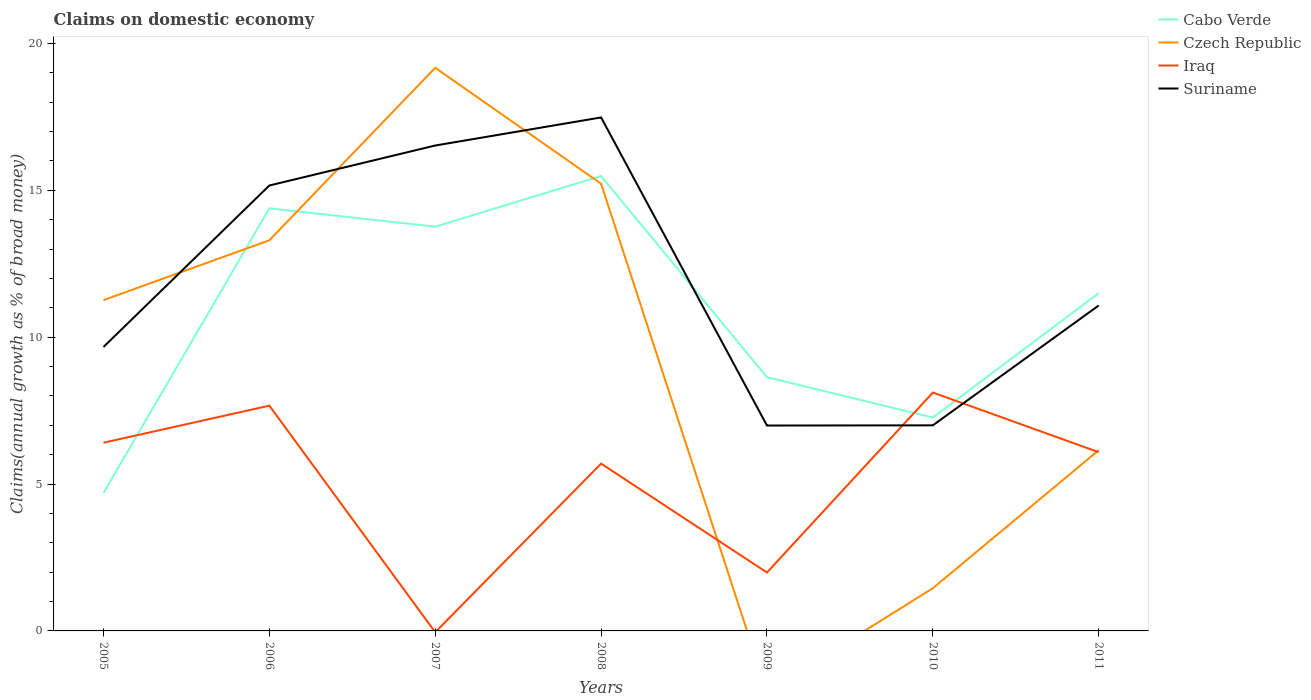Does the line corresponding to Czech Republic intersect with the line corresponding to Cabo Verde?
Your answer should be very brief. Yes. Is the number of lines equal to the number of legend labels?
Your answer should be compact. No. What is the total percentage of broad money claimed on domestic economy in Czech Republic in the graph?
Offer a very short reply. -1.93. What is the difference between the highest and the second highest percentage of broad money claimed on domestic economy in Iraq?
Your response must be concise. 8.12. How many lines are there?
Provide a short and direct response. 4. What is the difference between two consecutive major ticks on the Y-axis?
Offer a terse response. 5. How many legend labels are there?
Your response must be concise. 4. How are the legend labels stacked?
Your response must be concise. Vertical. What is the title of the graph?
Offer a very short reply. Claims on domestic economy. Does "Kazakhstan" appear as one of the legend labels in the graph?
Provide a succinct answer. No. What is the label or title of the Y-axis?
Provide a succinct answer. Claims(annual growth as % of broad money). What is the Claims(annual growth as % of broad money) of Cabo Verde in 2005?
Offer a very short reply. 4.7. What is the Claims(annual growth as % of broad money) of Czech Republic in 2005?
Give a very brief answer. 11.26. What is the Claims(annual growth as % of broad money) of Iraq in 2005?
Keep it short and to the point. 6.41. What is the Claims(annual growth as % of broad money) of Suriname in 2005?
Provide a short and direct response. 9.67. What is the Claims(annual growth as % of broad money) of Cabo Verde in 2006?
Your answer should be compact. 14.39. What is the Claims(annual growth as % of broad money) of Czech Republic in 2006?
Make the answer very short. 13.3. What is the Claims(annual growth as % of broad money) of Iraq in 2006?
Your answer should be very brief. 7.67. What is the Claims(annual growth as % of broad money) in Suriname in 2006?
Your answer should be compact. 15.16. What is the Claims(annual growth as % of broad money) in Cabo Verde in 2007?
Ensure brevity in your answer.  13.76. What is the Claims(annual growth as % of broad money) in Czech Republic in 2007?
Give a very brief answer. 19.17. What is the Claims(annual growth as % of broad money) of Suriname in 2007?
Ensure brevity in your answer.  16.53. What is the Claims(annual growth as % of broad money) of Cabo Verde in 2008?
Your answer should be very brief. 15.49. What is the Claims(annual growth as % of broad money) in Czech Republic in 2008?
Provide a short and direct response. 15.22. What is the Claims(annual growth as % of broad money) in Iraq in 2008?
Offer a very short reply. 5.7. What is the Claims(annual growth as % of broad money) in Suriname in 2008?
Your response must be concise. 17.48. What is the Claims(annual growth as % of broad money) of Cabo Verde in 2009?
Give a very brief answer. 8.64. What is the Claims(annual growth as % of broad money) of Iraq in 2009?
Keep it short and to the point. 1.99. What is the Claims(annual growth as % of broad money) in Suriname in 2009?
Ensure brevity in your answer.  6.99. What is the Claims(annual growth as % of broad money) of Cabo Verde in 2010?
Offer a very short reply. 7.26. What is the Claims(annual growth as % of broad money) of Czech Republic in 2010?
Make the answer very short. 1.45. What is the Claims(annual growth as % of broad money) in Iraq in 2010?
Offer a very short reply. 8.12. What is the Claims(annual growth as % of broad money) of Suriname in 2010?
Your answer should be compact. 7. What is the Claims(annual growth as % of broad money) of Cabo Verde in 2011?
Give a very brief answer. 11.5. What is the Claims(annual growth as % of broad money) in Czech Republic in 2011?
Offer a very short reply. 6.15. What is the Claims(annual growth as % of broad money) in Iraq in 2011?
Ensure brevity in your answer.  6.09. What is the Claims(annual growth as % of broad money) of Suriname in 2011?
Provide a short and direct response. 11.08. Across all years, what is the maximum Claims(annual growth as % of broad money) in Cabo Verde?
Provide a succinct answer. 15.49. Across all years, what is the maximum Claims(annual growth as % of broad money) of Czech Republic?
Make the answer very short. 19.17. Across all years, what is the maximum Claims(annual growth as % of broad money) in Iraq?
Ensure brevity in your answer.  8.12. Across all years, what is the maximum Claims(annual growth as % of broad money) in Suriname?
Make the answer very short. 17.48. Across all years, what is the minimum Claims(annual growth as % of broad money) of Cabo Verde?
Offer a terse response. 4.7. Across all years, what is the minimum Claims(annual growth as % of broad money) in Czech Republic?
Ensure brevity in your answer.  0. Across all years, what is the minimum Claims(annual growth as % of broad money) of Suriname?
Provide a short and direct response. 6.99. What is the total Claims(annual growth as % of broad money) of Cabo Verde in the graph?
Make the answer very short. 75.74. What is the total Claims(annual growth as % of broad money) of Czech Republic in the graph?
Ensure brevity in your answer.  66.57. What is the total Claims(annual growth as % of broad money) of Iraq in the graph?
Your response must be concise. 35.96. What is the total Claims(annual growth as % of broad money) in Suriname in the graph?
Provide a short and direct response. 83.91. What is the difference between the Claims(annual growth as % of broad money) in Cabo Verde in 2005 and that in 2006?
Provide a short and direct response. -9.69. What is the difference between the Claims(annual growth as % of broad money) of Czech Republic in 2005 and that in 2006?
Your answer should be very brief. -2.04. What is the difference between the Claims(annual growth as % of broad money) in Iraq in 2005 and that in 2006?
Offer a terse response. -1.26. What is the difference between the Claims(annual growth as % of broad money) of Suriname in 2005 and that in 2006?
Provide a short and direct response. -5.5. What is the difference between the Claims(annual growth as % of broad money) of Cabo Verde in 2005 and that in 2007?
Provide a short and direct response. -9.07. What is the difference between the Claims(annual growth as % of broad money) in Czech Republic in 2005 and that in 2007?
Provide a succinct answer. -7.91. What is the difference between the Claims(annual growth as % of broad money) in Suriname in 2005 and that in 2007?
Make the answer very short. -6.86. What is the difference between the Claims(annual growth as % of broad money) of Cabo Verde in 2005 and that in 2008?
Make the answer very short. -10.79. What is the difference between the Claims(annual growth as % of broad money) in Czech Republic in 2005 and that in 2008?
Provide a short and direct response. -3.96. What is the difference between the Claims(annual growth as % of broad money) of Iraq in 2005 and that in 2008?
Offer a terse response. 0.71. What is the difference between the Claims(annual growth as % of broad money) of Suriname in 2005 and that in 2008?
Offer a terse response. -7.82. What is the difference between the Claims(annual growth as % of broad money) of Cabo Verde in 2005 and that in 2009?
Your answer should be compact. -3.94. What is the difference between the Claims(annual growth as % of broad money) in Iraq in 2005 and that in 2009?
Your answer should be very brief. 4.42. What is the difference between the Claims(annual growth as % of broad money) of Suriname in 2005 and that in 2009?
Provide a short and direct response. 2.67. What is the difference between the Claims(annual growth as % of broad money) of Cabo Verde in 2005 and that in 2010?
Ensure brevity in your answer.  -2.57. What is the difference between the Claims(annual growth as % of broad money) of Czech Republic in 2005 and that in 2010?
Keep it short and to the point. 9.81. What is the difference between the Claims(annual growth as % of broad money) in Iraq in 2005 and that in 2010?
Offer a very short reply. -1.71. What is the difference between the Claims(annual growth as % of broad money) in Suriname in 2005 and that in 2010?
Your response must be concise. 2.67. What is the difference between the Claims(annual growth as % of broad money) of Cabo Verde in 2005 and that in 2011?
Offer a very short reply. -6.8. What is the difference between the Claims(annual growth as % of broad money) in Czech Republic in 2005 and that in 2011?
Give a very brief answer. 5.11. What is the difference between the Claims(annual growth as % of broad money) of Iraq in 2005 and that in 2011?
Your response must be concise. 0.32. What is the difference between the Claims(annual growth as % of broad money) in Suriname in 2005 and that in 2011?
Offer a very short reply. -1.41. What is the difference between the Claims(annual growth as % of broad money) of Cabo Verde in 2006 and that in 2007?
Ensure brevity in your answer.  0.62. What is the difference between the Claims(annual growth as % of broad money) of Czech Republic in 2006 and that in 2007?
Your answer should be very brief. -5.87. What is the difference between the Claims(annual growth as % of broad money) of Suriname in 2006 and that in 2007?
Give a very brief answer. -1.36. What is the difference between the Claims(annual growth as % of broad money) of Cabo Verde in 2006 and that in 2008?
Your answer should be compact. -1.1. What is the difference between the Claims(annual growth as % of broad money) in Czech Republic in 2006 and that in 2008?
Give a very brief answer. -1.93. What is the difference between the Claims(annual growth as % of broad money) in Iraq in 2006 and that in 2008?
Ensure brevity in your answer.  1.97. What is the difference between the Claims(annual growth as % of broad money) of Suriname in 2006 and that in 2008?
Your answer should be very brief. -2.32. What is the difference between the Claims(annual growth as % of broad money) of Cabo Verde in 2006 and that in 2009?
Provide a succinct answer. 5.75. What is the difference between the Claims(annual growth as % of broad money) of Iraq in 2006 and that in 2009?
Ensure brevity in your answer.  5.68. What is the difference between the Claims(annual growth as % of broad money) of Suriname in 2006 and that in 2009?
Offer a very short reply. 8.17. What is the difference between the Claims(annual growth as % of broad money) of Cabo Verde in 2006 and that in 2010?
Your answer should be compact. 7.12. What is the difference between the Claims(annual growth as % of broad money) in Czech Republic in 2006 and that in 2010?
Provide a short and direct response. 11.84. What is the difference between the Claims(annual growth as % of broad money) of Iraq in 2006 and that in 2010?
Give a very brief answer. -0.45. What is the difference between the Claims(annual growth as % of broad money) of Suriname in 2006 and that in 2010?
Provide a short and direct response. 8.17. What is the difference between the Claims(annual growth as % of broad money) of Cabo Verde in 2006 and that in 2011?
Offer a very short reply. 2.89. What is the difference between the Claims(annual growth as % of broad money) in Czech Republic in 2006 and that in 2011?
Your response must be concise. 7.15. What is the difference between the Claims(annual growth as % of broad money) in Iraq in 2006 and that in 2011?
Provide a short and direct response. 1.58. What is the difference between the Claims(annual growth as % of broad money) in Suriname in 2006 and that in 2011?
Keep it short and to the point. 4.09. What is the difference between the Claims(annual growth as % of broad money) in Cabo Verde in 2007 and that in 2008?
Offer a very short reply. -1.72. What is the difference between the Claims(annual growth as % of broad money) in Czech Republic in 2007 and that in 2008?
Provide a succinct answer. 3.95. What is the difference between the Claims(annual growth as % of broad money) of Suriname in 2007 and that in 2008?
Keep it short and to the point. -0.96. What is the difference between the Claims(annual growth as % of broad money) of Cabo Verde in 2007 and that in 2009?
Give a very brief answer. 5.12. What is the difference between the Claims(annual growth as % of broad money) of Suriname in 2007 and that in 2009?
Your answer should be very brief. 9.53. What is the difference between the Claims(annual growth as % of broad money) in Cabo Verde in 2007 and that in 2010?
Provide a short and direct response. 6.5. What is the difference between the Claims(annual growth as % of broad money) of Czech Republic in 2007 and that in 2010?
Your answer should be compact. 17.72. What is the difference between the Claims(annual growth as % of broad money) of Suriname in 2007 and that in 2010?
Provide a succinct answer. 9.53. What is the difference between the Claims(annual growth as % of broad money) of Cabo Verde in 2007 and that in 2011?
Offer a terse response. 2.26. What is the difference between the Claims(annual growth as % of broad money) of Czech Republic in 2007 and that in 2011?
Your answer should be compact. 13.02. What is the difference between the Claims(annual growth as % of broad money) of Suriname in 2007 and that in 2011?
Keep it short and to the point. 5.45. What is the difference between the Claims(annual growth as % of broad money) of Cabo Verde in 2008 and that in 2009?
Provide a short and direct response. 6.85. What is the difference between the Claims(annual growth as % of broad money) of Iraq in 2008 and that in 2009?
Make the answer very short. 3.71. What is the difference between the Claims(annual growth as % of broad money) of Suriname in 2008 and that in 2009?
Offer a terse response. 10.49. What is the difference between the Claims(annual growth as % of broad money) of Cabo Verde in 2008 and that in 2010?
Give a very brief answer. 8.22. What is the difference between the Claims(annual growth as % of broad money) of Czech Republic in 2008 and that in 2010?
Your response must be concise. 13.77. What is the difference between the Claims(annual growth as % of broad money) of Iraq in 2008 and that in 2010?
Your response must be concise. -2.42. What is the difference between the Claims(annual growth as % of broad money) in Suriname in 2008 and that in 2010?
Offer a very short reply. 10.48. What is the difference between the Claims(annual growth as % of broad money) of Cabo Verde in 2008 and that in 2011?
Make the answer very short. 3.99. What is the difference between the Claims(annual growth as % of broad money) of Czech Republic in 2008 and that in 2011?
Your answer should be very brief. 9.07. What is the difference between the Claims(annual growth as % of broad money) of Iraq in 2008 and that in 2011?
Your response must be concise. -0.39. What is the difference between the Claims(annual growth as % of broad money) in Suriname in 2008 and that in 2011?
Give a very brief answer. 6.4. What is the difference between the Claims(annual growth as % of broad money) in Cabo Verde in 2009 and that in 2010?
Give a very brief answer. 1.37. What is the difference between the Claims(annual growth as % of broad money) in Iraq in 2009 and that in 2010?
Your response must be concise. -6.13. What is the difference between the Claims(annual growth as % of broad money) in Suriname in 2009 and that in 2010?
Your answer should be compact. -0.01. What is the difference between the Claims(annual growth as % of broad money) in Cabo Verde in 2009 and that in 2011?
Your answer should be very brief. -2.86. What is the difference between the Claims(annual growth as % of broad money) in Iraq in 2009 and that in 2011?
Your answer should be compact. -4.1. What is the difference between the Claims(annual growth as % of broad money) of Suriname in 2009 and that in 2011?
Offer a terse response. -4.09. What is the difference between the Claims(annual growth as % of broad money) in Cabo Verde in 2010 and that in 2011?
Offer a very short reply. -4.24. What is the difference between the Claims(annual growth as % of broad money) in Czech Republic in 2010 and that in 2011?
Your response must be concise. -4.7. What is the difference between the Claims(annual growth as % of broad money) in Iraq in 2010 and that in 2011?
Ensure brevity in your answer.  2.03. What is the difference between the Claims(annual growth as % of broad money) in Suriname in 2010 and that in 2011?
Make the answer very short. -4.08. What is the difference between the Claims(annual growth as % of broad money) of Cabo Verde in 2005 and the Claims(annual growth as % of broad money) of Czech Republic in 2006?
Your answer should be very brief. -8.6. What is the difference between the Claims(annual growth as % of broad money) in Cabo Verde in 2005 and the Claims(annual growth as % of broad money) in Iraq in 2006?
Make the answer very short. -2.97. What is the difference between the Claims(annual growth as % of broad money) in Cabo Verde in 2005 and the Claims(annual growth as % of broad money) in Suriname in 2006?
Ensure brevity in your answer.  -10.47. What is the difference between the Claims(annual growth as % of broad money) in Czech Republic in 2005 and the Claims(annual growth as % of broad money) in Iraq in 2006?
Offer a terse response. 3.59. What is the difference between the Claims(annual growth as % of broad money) in Czech Republic in 2005 and the Claims(annual growth as % of broad money) in Suriname in 2006?
Offer a terse response. -3.9. What is the difference between the Claims(annual growth as % of broad money) in Iraq in 2005 and the Claims(annual growth as % of broad money) in Suriname in 2006?
Provide a short and direct response. -8.76. What is the difference between the Claims(annual growth as % of broad money) of Cabo Verde in 2005 and the Claims(annual growth as % of broad money) of Czech Republic in 2007?
Your answer should be very brief. -14.48. What is the difference between the Claims(annual growth as % of broad money) of Cabo Verde in 2005 and the Claims(annual growth as % of broad money) of Suriname in 2007?
Provide a succinct answer. -11.83. What is the difference between the Claims(annual growth as % of broad money) in Czech Republic in 2005 and the Claims(annual growth as % of broad money) in Suriname in 2007?
Make the answer very short. -5.26. What is the difference between the Claims(annual growth as % of broad money) in Iraq in 2005 and the Claims(annual growth as % of broad money) in Suriname in 2007?
Provide a short and direct response. -10.12. What is the difference between the Claims(annual growth as % of broad money) of Cabo Verde in 2005 and the Claims(annual growth as % of broad money) of Czech Republic in 2008?
Make the answer very short. -10.53. What is the difference between the Claims(annual growth as % of broad money) of Cabo Verde in 2005 and the Claims(annual growth as % of broad money) of Iraq in 2008?
Provide a short and direct response. -1. What is the difference between the Claims(annual growth as % of broad money) in Cabo Verde in 2005 and the Claims(annual growth as % of broad money) in Suriname in 2008?
Ensure brevity in your answer.  -12.78. What is the difference between the Claims(annual growth as % of broad money) of Czech Republic in 2005 and the Claims(annual growth as % of broad money) of Iraq in 2008?
Offer a terse response. 5.57. What is the difference between the Claims(annual growth as % of broad money) in Czech Republic in 2005 and the Claims(annual growth as % of broad money) in Suriname in 2008?
Make the answer very short. -6.22. What is the difference between the Claims(annual growth as % of broad money) of Iraq in 2005 and the Claims(annual growth as % of broad money) of Suriname in 2008?
Your answer should be very brief. -11.07. What is the difference between the Claims(annual growth as % of broad money) of Cabo Verde in 2005 and the Claims(annual growth as % of broad money) of Iraq in 2009?
Provide a short and direct response. 2.71. What is the difference between the Claims(annual growth as % of broad money) of Cabo Verde in 2005 and the Claims(annual growth as % of broad money) of Suriname in 2009?
Give a very brief answer. -2.29. What is the difference between the Claims(annual growth as % of broad money) of Czech Republic in 2005 and the Claims(annual growth as % of broad money) of Iraq in 2009?
Your answer should be very brief. 9.27. What is the difference between the Claims(annual growth as % of broad money) in Czech Republic in 2005 and the Claims(annual growth as % of broad money) in Suriname in 2009?
Provide a succinct answer. 4.27. What is the difference between the Claims(annual growth as % of broad money) in Iraq in 2005 and the Claims(annual growth as % of broad money) in Suriname in 2009?
Provide a succinct answer. -0.58. What is the difference between the Claims(annual growth as % of broad money) of Cabo Verde in 2005 and the Claims(annual growth as % of broad money) of Czech Republic in 2010?
Provide a succinct answer. 3.24. What is the difference between the Claims(annual growth as % of broad money) in Cabo Verde in 2005 and the Claims(annual growth as % of broad money) in Iraq in 2010?
Keep it short and to the point. -3.42. What is the difference between the Claims(annual growth as % of broad money) of Cabo Verde in 2005 and the Claims(annual growth as % of broad money) of Suriname in 2010?
Provide a succinct answer. -2.3. What is the difference between the Claims(annual growth as % of broad money) in Czech Republic in 2005 and the Claims(annual growth as % of broad money) in Iraq in 2010?
Make the answer very short. 3.15. What is the difference between the Claims(annual growth as % of broad money) in Czech Republic in 2005 and the Claims(annual growth as % of broad money) in Suriname in 2010?
Ensure brevity in your answer.  4.26. What is the difference between the Claims(annual growth as % of broad money) in Iraq in 2005 and the Claims(annual growth as % of broad money) in Suriname in 2010?
Offer a terse response. -0.59. What is the difference between the Claims(annual growth as % of broad money) of Cabo Verde in 2005 and the Claims(annual growth as % of broad money) of Czech Republic in 2011?
Offer a terse response. -1.46. What is the difference between the Claims(annual growth as % of broad money) of Cabo Verde in 2005 and the Claims(annual growth as % of broad money) of Iraq in 2011?
Your answer should be very brief. -1.39. What is the difference between the Claims(annual growth as % of broad money) of Cabo Verde in 2005 and the Claims(annual growth as % of broad money) of Suriname in 2011?
Your response must be concise. -6.38. What is the difference between the Claims(annual growth as % of broad money) of Czech Republic in 2005 and the Claims(annual growth as % of broad money) of Iraq in 2011?
Provide a succinct answer. 5.18. What is the difference between the Claims(annual growth as % of broad money) of Czech Republic in 2005 and the Claims(annual growth as % of broad money) of Suriname in 2011?
Your answer should be compact. 0.18. What is the difference between the Claims(annual growth as % of broad money) in Iraq in 2005 and the Claims(annual growth as % of broad money) in Suriname in 2011?
Give a very brief answer. -4.67. What is the difference between the Claims(annual growth as % of broad money) in Cabo Verde in 2006 and the Claims(annual growth as % of broad money) in Czech Republic in 2007?
Your response must be concise. -4.79. What is the difference between the Claims(annual growth as % of broad money) in Cabo Verde in 2006 and the Claims(annual growth as % of broad money) in Suriname in 2007?
Your answer should be compact. -2.14. What is the difference between the Claims(annual growth as % of broad money) of Czech Republic in 2006 and the Claims(annual growth as % of broad money) of Suriname in 2007?
Ensure brevity in your answer.  -3.23. What is the difference between the Claims(annual growth as % of broad money) of Iraq in 2006 and the Claims(annual growth as % of broad money) of Suriname in 2007?
Your answer should be compact. -8.86. What is the difference between the Claims(annual growth as % of broad money) of Cabo Verde in 2006 and the Claims(annual growth as % of broad money) of Czech Republic in 2008?
Keep it short and to the point. -0.84. What is the difference between the Claims(annual growth as % of broad money) in Cabo Verde in 2006 and the Claims(annual growth as % of broad money) in Iraq in 2008?
Offer a terse response. 8.69. What is the difference between the Claims(annual growth as % of broad money) in Cabo Verde in 2006 and the Claims(annual growth as % of broad money) in Suriname in 2008?
Your answer should be compact. -3.09. What is the difference between the Claims(annual growth as % of broad money) of Czech Republic in 2006 and the Claims(annual growth as % of broad money) of Iraq in 2008?
Provide a short and direct response. 7.6. What is the difference between the Claims(annual growth as % of broad money) of Czech Republic in 2006 and the Claims(annual growth as % of broad money) of Suriname in 2008?
Provide a short and direct response. -4.18. What is the difference between the Claims(annual growth as % of broad money) in Iraq in 2006 and the Claims(annual growth as % of broad money) in Suriname in 2008?
Your answer should be very brief. -9.81. What is the difference between the Claims(annual growth as % of broad money) of Cabo Verde in 2006 and the Claims(annual growth as % of broad money) of Iraq in 2009?
Your answer should be compact. 12.4. What is the difference between the Claims(annual growth as % of broad money) of Cabo Verde in 2006 and the Claims(annual growth as % of broad money) of Suriname in 2009?
Your answer should be very brief. 7.39. What is the difference between the Claims(annual growth as % of broad money) in Czech Republic in 2006 and the Claims(annual growth as % of broad money) in Iraq in 2009?
Ensure brevity in your answer.  11.31. What is the difference between the Claims(annual growth as % of broad money) of Czech Republic in 2006 and the Claims(annual growth as % of broad money) of Suriname in 2009?
Provide a succinct answer. 6.31. What is the difference between the Claims(annual growth as % of broad money) in Iraq in 2006 and the Claims(annual growth as % of broad money) in Suriname in 2009?
Your answer should be compact. 0.68. What is the difference between the Claims(annual growth as % of broad money) of Cabo Verde in 2006 and the Claims(annual growth as % of broad money) of Czech Republic in 2010?
Ensure brevity in your answer.  12.93. What is the difference between the Claims(annual growth as % of broad money) in Cabo Verde in 2006 and the Claims(annual growth as % of broad money) in Iraq in 2010?
Your response must be concise. 6.27. What is the difference between the Claims(annual growth as % of broad money) in Cabo Verde in 2006 and the Claims(annual growth as % of broad money) in Suriname in 2010?
Provide a succinct answer. 7.39. What is the difference between the Claims(annual growth as % of broad money) in Czech Republic in 2006 and the Claims(annual growth as % of broad money) in Iraq in 2010?
Make the answer very short. 5.18. What is the difference between the Claims(annual growth as % of broad money) in Czech Republic in 2006 and the Claims(annual growth as % of broad money) in Suriname in 2010?
Give a very brief answer. 6.3. What is the difference between the Claims(annual growth as % of broad money) in Iraq in 2006 and the Claims(annual growth as % of broad money) in Suriname in 2010?
Your response must be concise. 0.67. What is the difference between the Claims(annual growth as % of broad money) of Cabo Verde in 2006 and the Claims(annual growth as % of broad money) of Czech Republic in 2011?
Offer a very short reply. 8.23. What is the difference between the Claims(annual growth as % of broad money) in Cabo Verde in 2006 and the Claims(annual growth as % of broad money) in Iraq in 2011?
Provide a short and direct response. 8.3. What is the difference between the Claims(annual growth as % of broad money) of Cabo Verde in 2006 and the Claims(annual growth as % of broad money) of Suriname in 2011?
Offer a very short reply. 3.31. What is the difference between the Claims(annual growth as % of broad money) in Czech Republic in 2006 and the Claims(annual growth as % of broad money) in Iraq in 2011?
Make the answer very short. 7.21. What is the difference between the Claims(annual growth as % of broad money) in Czech Republic in 2006 and the Claims(annual growth as % of broad money) in Suriname in 2011?
Your response must be concise. 2.22. What is the difference between the Claims(annual growth as % of broad money) of Iraq in 2006 and the Claims(annual growth as % of broad money) of Suriname in 2011?
Give a very brief answer. -3.41. What is the difference between the Claims(annual growth as % of broad money) in Cabo Verde in 2007 and the Claims(annual growth as % of broad money) in Czech Republic in 2008?
Your response must be concise. -1.46. What is the difference between the Claims(annual growth as % of broad money) of Cabo Verde in 2007 and the Claims(annual growth as % of broad money) of Iraq in 2008?
Provide a short and direct response. 8.07. What is the difference between the Claims(annual growth as % of broad money) in Cabo Verde in 2007 and the Claims(annual growth as % of broad money) in Suriname in 2008?
Offer a very short reply. -3.72. What is the difference between the Claims(annual growth as % of broad money) of Czech Republic in 2007 and the Claims(annual growth as % of broad money) of Iraq in 2008?
Give a very brief answer. 13.48. What is the difference between the Claims(annual growth as % of broad money) of Czech Republic in 2007 and the Claims(annual growth as % of broad money) of Suriname in 2008?
Provide a succinct answer. 1.69. What is the difference between the Claims(annual growth as % of broad money) in Cabo Verde in 2007 and the Claims(annual growth as % of broad money) in Iraq in 2009?
Provide a succinct answer. 11.77. What is the difference between the Claims(annual growth as % of broad money) of Cabo Verde in 2007 and the Claims(annual growth as % of broad money) of Suriname in 2009?
Provide a short and direct response. 6.77. What is the difference between the Claims(annual growth as % of broad money) in Czech Republic in 2007 and the Claims(annual growth as % of broad money) in Iraq in 2009?
Keep it short and to the point. 17.18. What is the difference between the Claims(annual growth as % of broad money) of Czech Republic in 2007 and the Claims(annual growth as % of broad money) of Suriname in 2009?
Offer a very short reply. 12.18. What is the difference between the Claims(annual growth as % of broad money) in Cabo Verde in 2007 and the Claims(annual growth as % of broad money) in Czech Republic in 2010?
Provide a succinct answer. 12.31. What is the difference between the Claims(annual growth as % of broad money) of Cabo Verde in 2007 and the Claims(annual growth as % of broad money) of Iraq in 2010?
Give a very brief answer. 5.65. What is the difference between the Claims(annual growth as % of broad money) in Cabo Verde in 2007 and the Claims(annual growth as % of broad money) in Suriname in 2010?
Provide a succinct answer. 6.76. What is the difference between the Claims(annual growth as % of broad money) in Czech Republic in 2007 and the Claims(annual growth as % of broad money) in Iraq in 2010?
Your response must be concise. 11.06. What is the difference between the Claims(annual growth as % of broad money) in Czech Republic in 2007 and the Claims(annual growth as % of broad money) in Suriname in 2010?
Your answer should be very brief. 12.17. What is the difference between the Claims(annual growth as % of broad money) in Cabo Verde in 2007 and the Claims(annual growth as % of broad money) in Czech Republic in 2011?
Give a very brief answer. 7.61. What is the difference between the Claims(annual growth as % of broad money) of Cabo Verde in 2007 and the Claims(annual growth as % of broad money) of Iraq in 2011?
Your response must be concise. 7.68. What is the difference between the Claims(annual growth as % of broad money) in Cabo Verde in 2007 and the Claims(annual growth as % of broad money) in Suriname in 2011?
Provide a short and direct response. 2.68. What is the difference between the Claims(annual growth as % of broad money) in Czech Republic in 2007 and the Claims(annual growth as % of broad money) in Iraq in 2011?
Keep it short and to the point. 13.09. What is the difference between the Claims(annual growth as % of broad money) of Czech Republic in 2007 and the Claims(annual growth as % of broad money) of Suriname in 2011?
Give a very brief answer. 8.09. What is the difference between the Claims(annual growth as % of broad money) of Cabo Verde in 2008 and the Claims(annual growth as % of broad money) of Iraq in 2009?
Provide a short and direct response. 13.5. What is the difference between the Claims(annual growth as % of broad money) of Cabo Verde in 2008 and the Claims(annual growth as % of broad money) of Suriname in 2009?
Give a very brief answer. 8.49. What is the difference between the Claims(annual growth as % of broad money) of Czech Republic in 2008 and the Claims(annual growth as % of broad money) of Iraq in 2009?
Ensure brevity in your answer.  13.24. What is the difference between the Claims(annual growth as % of broad money) of Czech Republic in 2008 and the Claims(annual growth as % of broad money) of Suriname in 2009?
Make the answer very short. 8.23. What is the difference between the Claims(annual growth as % of broad money) in Iraq in 2008 and the Claims(annual growth as % of broad money) in Suriname in 2009?
Keep it short and to the point. -1.3. What is the difference between the Claims(annual growth as % of broad money) of Cabo Verde in 2008 and the Claims(annual growth as % of broad money) of Czech Republic in 2010?
Your answer should be compact. 14.03. What is the difference between the Claims(annual growth as % of broad money) in Cabo Verde in 2008 and the Claims(annual growth as % of broad money) in Iraq in 2010?
Provide a short and direct response. 7.37. What is the difference between the Claims(annual growth as % of broad money) in Cabo Verde in 2008 and the Claims(annual growth as % of broad money) in Suriname in 2010?
Offer a terse response. 8.49. What is the difference between the Claims(annual growth as % of broad money) in Czech Republic in 2008 and the Claims(annual growth as % of broad money) in Iraq in 2010?
Keep it short and to the point. 7.11. What is the difference between the Claims(annual growth as % of broad money) in Czech Republic in 2008 and the Claims(annual growth as % of broad money) in Suriname in 2010?
Provide a short and direct response. 8.23. What is the difference between the Claims(annual growth as % of broad money) of Iraq in 2008 and the Claims(annual growth as % of broad money) of Suriname in 2010?
Offer a very short reply. -1.3. What is the difference between the Claims(annual growth as % of broad money) of Cabo Verde in 2008 and the Claims(annual growth as % of broad money) of Czech Republic in 2011?
Your response must be concise. 9.33. What is the difference between the Claims(annual growth as % of broad money) of Cabo Verde in 2008 and the Claims(annual growth as % of broad money) of Iraq in 2011?
Your answer should be compact. 9.4. What is the difference between the Claims(annual growth as % of broad money) in Cabo Verde in 2008 and the Claims(annual growth as % of broad money) in Suriname in 2011?
Your answer should be compact. 4.41. What is the difference between the Claims(annual growth as % of broad money) of Czech Republic in 2008 and the Claims(annual growth as % of broad money) of Iraq in 2011?
Offer a terse response. 9.14. What is the difference between the Claims(annual growth as % of broad money) of Czech Republic in 2008 and the Claims(annual growth as % of broad money) of Suriname in 2011?
Give a very brief answer. 4.15. What is the difference between the Claims(annual growth as % of broad money) of Iraq in 2008 and the Claims(annual growth as % of broad money) of Suriname in 2011?
Make the answer very short. -5.38. What is the difference between the Claims(annual growth as % of broad money) in Cabo Verde in 2009 and the Claims(annual growth as % of broad money) in Czech Republic in 2010?
Your response must be concise. 7.18. What is the difference between the Claims(annual growth as % of broad money) in Cabo Verde in 2009 and the Claims(annual growth as % of broad money) in Iraq in 2010?
Keep it short and to the point. 0.52. What is the difference between the Claims(annual growth as % of broad money) of Cabo Verde in 2009 and the Claims(annual growth as % of broad money) of Suriname in 2010?
Keep it short and to the point. 1.64. What is the difference between the Claims(annual growth as % of broad money) in Iraq in 2009 and the Claims(annual growth as % of broad money) in Suriname in 2010?
Offer a terse response. -5.01. What is the difference between the Claims(annual growth as % of broad money) of Cabo Verde in 2009 and the Claims(annual growth as % of broad money) of Czech Republic in 2011?
Offer a terse response. 2.49. What is the difference between the Claims(annual growth as % of broad money) of Cabo Verde in 2009 and the Claims(annual growth as % of broad money) of Iraq in 2011?
Your response must be concise. 2.55. What is the difference between the Claims(annual growth as % of broad money) in Cabo Verde in 2009 and the Claims(annual growth as % of broad money) in Suriname in 2011?
Offer a very short reply. -2.44. What is the difference between the Claims(annual growth as % of broad money) of Iraq in 2009 and the Claims(annual growth as % of broad money) of Suriname in 2011?
Ensure brevity in your answer.  -9.09. What is the difference between the Claims(annual growth as % of broad money) in Cabo Verde in 2010 and the Claims(annual growth as % of broad money) in Czech Republic in 2011?
Offer a very short reply. 1.11. What is the difference between the Claims(annual growth as % of broad money) in Cabo Verde in 2010 and the Claims(annual growth as % of broad money) in Iraq in 2011?
Make the answer very short. 1.18. What is the difference between the Claims(annual growth as % of broad money) in Cabo Verde in 2010 and the Claims(annual growth as % of broad money) in Suriname in 2011?
Provide a short and direct response. -3.81. What is the difference between the Claims(annual growth as % of broad money) of Czech Republic in 2010 and the Claims(annual growth as % of broad money) of Iraq in 2011?
Provide a succinct answer. -4.63. What is the difference between the Claims(annual growth as % of broad money) of Czech Republic in 2010 and the Claims(annual growth as % of broad money) of Suriname in 2011?
Your answer should be very brief. -9.62. What is the difference between the Claims(annual growth as % of broad money) of Iraq in 2010 and the Claims(annual growth as % of broad money) of Suriname in 2011?
Offer a very short reply. -2.96. What is the average Claims(annual growth as % of broad money) of Cabo Verde per year?
Provide a short and direct response. 10.82. What is the average Claims(annual growth as % of broad money) in Czech Republic per year?
Offer a terse response. 9.51. What is the average Claims(annual growth as % of broad money) in Iraq per year?
Offer a very short reply. 5.14. What is the average Claims(annual growth as % of broad money) of Suriname per year?
Make the answer very short. 11.99. In the year 2005, what is the difference between the Claims(annual growth as % of broad money) in Cabo Verde and Claims(annual growth as % of broad money) in Czech Republic?
Your answer should be compact. -6.56. In the year 2005, what is the difference between the Claims(annual growth as % of broad money) of Cabo Verde and Claims(annual growth as % of broad money) of Iraq?
Provide a succinct answer. -1.71. In the year 2005, what is the difference between the Claims(annual growth as % of broad money) of Cabo Verde and Claims(annual growth as % of broad money) of Suriname?
Ensure brevity in your answer.  -4.97. In the year 2005, what is the difference between the Claims(annual growth as % of broad money) of Czech Republic and Claims(annual growth as % of broad money) of Iraq?
Keep it short and to the point. 4.85. In the year 2005, what is the difference between the Claims(annual growth as % of broad money) in Czech Republic and Claims(annual growth as % of broad money) in Suriname?
Ensure brevity in your answer.  1.6. In the year 2005, what is the difference between the Claims(annual growth as % of broad money) in Iraq and Claims(annual growth as % of broad money) in Suriname?
Give a very brief answer. -3.26. In the year 2006, what is the difference between the Claims(annual growth as % of broad money) in Cabo Verde and Claims(annual growth as % of broad money) in Czech Republic?
Offer a terse response. 1.09. In the year 2006, what is the difference between the Claims(annual growth as % of broad money) in Cabo Verde and Claims(annual growth as % of broad money) in Iraq?
Offer a very short reply. 6.72. In the year 2006, what is the difference between the Claims(annual growth as % of broad money) of Cabo Verde and Claims(annual growth as % of broad money) of Suriname?
Make the answer very short. -0.78. In the year 2006, what is the difference between the Claims(annual growth as % of broad money) in Czech Republic and Claims(annual growth as % of broad money) in Iraq?
Give a very brief answer. 5.63. In the year 2006, what is the difference between the Claims(annual growth as % of broad money) in Czech Republic and Claims(annual growth as % of broad money) in Suriname?
Ensure brevity in your answer.  -1.87. In the year 2006, what is the difference between the Claims(annual growth as % of broad money) of Iraq and Claims(annual growth as % of broad money) of Suriname?
Provide a short and direct response. -7.5. In the year 2007, what is the difference between the Claims(annual growth as % of broad money) in Cabo Verde and Claims(annual growth as % of broad money) in Czech Republic?
Provide a short and direct response. -5.41. In the year 2007, what is the difference between the Claims(annual growth as % of broad money) of Cabo Verde and Claims(annual growth as % of broad money) of Suriname?
Offer a terse response. -2.76. In the year 2007, what is the difference between the Claims(annual growth as % of broad money) in Czech Republic and Claims(annual growth as % of broad money) in Suriname?
Give a very brief answer. 2.65. In the year 2008, what is the difference between the Claims(annual growth as % of broad money) of Cabo Verde and Claims(annual growth as % of broad money) of Czech Republic?
Offer a very short reply. 0.26. In the year 2008, what is the difference between the Claims(annual growth as % of broad money) in Cabo Verde and Claims(annual growth as % of broad money) in Iraq?
Give a very brief answer. 9.79. In the year 2008, what is the difference between the Claims(annual growth as % of broad money) of Cabo Verde and Claims(annual growth as % of broad money) of Suriname?
Give a very brief answer. -1.99. In the year 2008, what is the difference between the Claims(annual growth as % of broad money) of Czech Republic and Claims(annual growth as % of broad money) of Iraq?
Keep it short and to the point. 9.53. In the year 2008, what is the difference between the Claims(annual growth as % of broad money) of Czech Republic and Claims(annual growth as % of broad money) of Suriname?
Provide a succinct answer. -2.26. In the year 2008, what is the difference between the Claims(annual growth as % of broad money) in Iraq and Claims(annual growth as % of broad money) in Suriname?
Provide a short and direct response. -11.79. In the year 2009, what is the difference between the Claims(annual growth as % of broad money) of Cabo Verde and Claims(annual growth as % of broad money) of Iraq?
Your response must be concise. 6.65. In the year 2009, what is the difference between the Claims(annual growth as % of broad money) of Cabo Verde and Claims(annual growth as % of broad money) of Suriname?
Ensure brevity in your answer.  1.65. In the year 2009, what is the difference between the Claims(annual growth as % of broad money) of Iraq and Claims(annual growth as % of broad money) of Suriname?
Give a very brief answer. -5. In the year 2010, what is the difference between the Claims(annual growth as % of broad money) of Cabo Verde and Claims(annual growth as % of broad money) of Czech Republic?
Offer a very short reply. 5.81. In the year 2010, what is the difference between the Claims(annual growth as % of broad money) in Cabo Verde and Claims(annual growth as % of broad money) in Iraq?
Give a very brief answer. -0.85. In the year 2010, what is the difference between the Claims(annual growth as % of broad money) of Cabo Verde and Claims(annual growth as % of broad money) of Suriname?
Offer a very short reply. 0.27. In the year 2010, what is the difference between the Claims(annual growth as % of broad money) of Czech Republic and Claims(annual growth as % of broad money) of Iraq?
Your answer should be very brief. -6.66. In the year 2010, what is the difference between the Claims(annual growth as % of broad money) in Czech Republic and Claims(annual growth as % of broad money) in Suriname?
Provide a short and direct response. -5.54. In the year 2010, what is the difference between the Claims(annual growth as % of broad money) in Iraq and Claims(annual growth as % of broad money) in Suriname?
Provide a short and direct response. 1.12. In the year 2011, what is the difference between the Claims(annual growth as % of broad money) of Cabo Verde and Claims(annual growth as % of broad money) of Czech Republic?
Your answer should be compact. 5.35. In the year 2011, what is the difference between the Claims(annual growth as % of broad money) of Cabo Verde and Claims(annual growth as % of broad money) of Iraq?
Your answer should be very brief. 5.42. In the year 2011, what is the difference between the Claims(annual growth as % of broad money) of Cabo Verde and Claims(annual growth as % of broad money) of Suriname?
Your answer should be very brief. 0.42. In the year 2011, what is the difference between the Claims(annual growth as % of broad money) of Czech Republic and Claims(annual growth as % of broad money) of Iraq?
Your answer should be compact. 0.07. In the year 2011, what is the difference between the Claims(annual growth as % of broad money) in Czech Republic and Claims(annual growth as % of broad money) in Suriname?
Your answer should be very brief. -4.93. In the year 2011, what is the difference between the Claims(annual growth as % of broad money) of Iraq and Claims(annual growth as % of broad money) of Suriname?
Your answer should be compact. -4.99. What is the ratio of the Claims(annual growth as % of broad money) of Cabo Verde in 2005 to that in 2006?
Your response must be concise. 0.33. What is the ratio of the Claims(annual growth as % of broad money) of Czech Republic in 2005 to that in 2006?
Give a very brief answer. 0.85. What is the ratio of the Claims(annual growth as % of broad money) of Iraq in 2005 to that in 2006?
Your response must be concise. 0.84. What is the ratio of the Claims(annual growth as % of broad money) in Suriname in 2005 to that in 2006?
Offer a very short reply. 0.64. What is the ratio of the Claims(annual growth as % of broad money) of Cabo Verde in 2005 to that in 2007?
Ensure brevity in your answer.  0.34. What is the ratio of the Claims(annual growth as % of broad money) of Czech Republic in 2005 to that in 2007?
Ensure brevity in your answer.  0.59. What is the ratio of the Claims(annual growth as % of broad money) of Suriname in 2005 to that in 2007?
Offer a terse response. 0.58. What is the ratio of the Claims(annual growth as % of broad money) in Cabo Verde in 2005 to that in 2008?
Provide a succinct answer. 0.3. What is the ratio of the Claims(annual growth as % of broad money) of Czech Republic in 2005 to that in 2008?
Make the answer very short. 0.74. What is the ratio of the Claims(annual growth as % of broad money) of Iraq in 2005 to that in 2008?
Ensure brevity in your answer.  1.12. What is the ratio of the Claims(annual growth as % of broad money) of Suriname in 2005 to that in 2008?
Ensure brevity in your answer.  0.55. What is the ratio of the Claims(annual growth as % of broad money) of Cabo Verde in 2005 to that in 2009?
Offer a terse response. 0.54. What is the ratio of the Claims(annual growth as % of broad money) of Iraq in 2005 to that in 2009?
Provide a short and direct response. 3.22. What is the ratio of the Claims(annual growth as % of broad money) of Suriname in 2005 to that in 2009?
Your response must be concise. 1.38. What is the ratio of the Claims(annual growth as % of broad money) in Cabo Verde in 2005 to that in 2010?
Make the answer very short. 0.65. What is the ratio of the Claims(annual growth as % of broad money) of Czech Republic in 2005 to that in 2010?
Provide a short and direct response. 7.74. What is the ratio of the Claims(annual growth as % of broad money) of Iraq in 2005 to that in 2010?
Provide a short and direct response. 0.79. What is the ratio of the Claims(annual growth as % of broad money) of Suriname in 2005 to that in 2010?
Make the answer very short. 1.38. What is the ratio of the Claims(annual growth as % of broad money) in Cabo Verde in 2005 to that in 2011?
Offer a very short reply. 0.41. What is the ratio of the Claims(annual growth as % of broad money) of Czech Republic in 2005 to that in 2011?
Provide a succinct answer. 1.83. What is the ratio of the Claims(annual growth as % of broad money) in Iraq in 2005 to that in 2011?
Your answer should be compact. 1.05. What is the ratio of the Claims(annual growth as % of broad money) of Suriname in 2005 to that in 2011?
Give a very brief answer. 0.87. What is the ratio of the Claims(annual growth as % of broad money) in Cabo Verde in 2006 to that in 2007?
Make the answer very short. 1.05. What is the ratio of the Claims(annual growth as % of broad money) in Czech Republic in 2006 to that in 2007?
Your answer should be very brief. 0.69. What is the ratio of the Claims(annual growth as % of broad money) of Suriname in 2006 to that in 2007?
Your response must be concise. 0.92. What is the ratio of the Claims(annual growth as % of broad money) in Cabo Verde in 2006 to that in 2008?
Make the answer very short. 0.93. What is the ratio of the Claims(annual growth as % of broad money) of Czech Republic in 2006 to that in 2008?
Your answer should be very brief. 0.87. What is the ratio of the Claims(annual growth as % of broad money) in Iraq in 2006 to that in 2008?
Your answer should be compact. 1.35. What is the ratio of the Claims(annual growth as % of broad money) in Suriname in 2006 to that in 2008?
Your answer should be compact. 0.87. What is the ratio of the Claims(annual growth as % of broad money) in Cabo Verde in 2006 to that in 2009?
Offer a very short reply. 1.67. What is the ratio of the Claims(annual growth as % of broad money) of Iraq in 2006 to that in 2009?
Keep it short and to the point. 3.86. What is the ratio of the Claims(annual growth as % of broad money) of Suriname in 2006 to that in 2009?
Provide a short and direct response. 2.17. What is the ratio of the Claims(annual growth as % of broad money) of Cabo Verde in 2006 to that in 2010?
Provide a succinct answer. 1.98. What is the ratio of the Claims(annual growth as % of broad money) in Czech Republic in 2006 to that in 2010?
Your answer should be compact. 9.15. What is the ratio of the Claims(annual growth as % of broad money) of Iraq in 2006 to that in 2010?
Your answer should be compact. 0.94. What is the ratio of the Claims(annual growth as % of broad money) in Suriname in 2006 to that in 2010?
Ensure brevity in your answer.  2.17. What is the ratio of the Claims(annual growth as % of broad money) in Cabo Verde in 2006 to that in 2011?
Make the answer very short. 1.25. What is the ratio of the Claims(annual growth as % of broad money) of Czech Republic in 2006 to that in 2011?
Provide a succinct answer. 2.16. What is the ratio of the Claims(annual growth as % of broad money) in Iraq in 2006 to that in 2011?
Make the answer very short. 1.26. What is the ratio of the Claims(annual growth as % of broad money) of Suriname in 2006 to that in 2011?
Provide a short and direct response. 1.37. What is the ratio of the Claims(annual growth as % of broad money) of Cabo Verde in 2007 to that in 2008?
Ensure brevity in your answer.  0.89. What is the ratio of the Claims(annual growth as % of broad money) in Czech Republic in 2007 to that in 2008?
Your response must be concise. 1.26. What is the ratio of the Claims(annual growth as % of broad money) of Suriname in 2007 to that in 2008?
Your answer should be very brief. 0.95. What is the ratio of the Claims(annual growth as % of broad money) of Cabo Verde in 2007 to that in 2009?
Ensure brevity in your answer.  1.59. What is the ratio of the Claims(annual growth as % of broad money) of Suriname in 2007 to that in 2009?
Offer a terse response. 2.36. What is the ratio of the Claims(annual growth as % of broad money) of Cabo Verde in 2007 to that in 2010?
Your response must be concise. 1.89. What is the ratio of the Claims(annual growth as % of broad money) of Czech Republic in 2007 to that in 2010?
Offer a terse response. 13.18. What is the ratio of the Claims(annual growth as % of broad money) of Suriname in 2007 to that in 2010?
Keep it short and to the point. 2.36. What is the ratio of the Claims(annual growth as % of broad money) in Cabo Verde in 2007 to that in 2011?
Make the answer very short. 1.2. What is the ratio of the Claims(annual growth as % of broad money) in Czech Republic in 2007 to that in 2011?
Offer a very short reply. 3.12. What is the ratio of the Claims(annual growth as % of broad money) of Suriname in 2007 to that in 2011?
Provide a short and direct response. 1.49. What is the ratio of the Claims(annual growth as % of broad money) of Cabo Verde in 2008 to that in 2009?
Keep it short and to the point. 1.79. What is the ratio of the Claims(annual growth as % of broad money) of Iraq in 2008 to that in 2009?
Give a very brief answer. 2.86. What is the ratio of the Claims(annual growth as % of broad money) in Cabo Verde in 2008 to that in 2010?
Provide a succinct answer. 2.13. What is the ratio of the Claims(annual growth as % of broad money) of Czech Republic in 2008 to that in 2010?
Ensure brevity in your answer.  10.47. What is the ratio of the Claims(annual growth as % of broad money) in Iraq in 2008 to that in 2010?
Keep it short and to the point. 0.7. What is the ratio of the Claims(annual growth as % of broad money) of Suriname in 2008 to that in 2010?
Your response must be concise. 2.5. What is the ratio of the Claims(annual growth as % of broad money) of Cabo Verde in 2008 to that in 2011?
Your answer should be very brief. 1.35. What is the ratio of the Claims(annual growth as % of broad money) in Czech Republic in 2008 to that in 2011?
Offer a very short reply. 2.47. What is the ratio of the Claims(annual growth as % of broad money) in Iraq in 2008 to that in 2011?
Offer a terse response. 0.94. What is the ratio of the Claims(annual growth as % of broad money) in Suriname in 2008 to that in 2011?
Provide a succinct answer. 1.58. What is the ratio of the Claims(annual growth as % of broad money) in Cabo Verde in 2009 to that in 2010?
Offer a very short reply. 1.19. What is the ratio of the Claims(annual growth as % of broad money) in Iraq in 2009 to that in 2010?
Your answer should be compact. 0.24. What is the ratio of the Claims(annual growth as % of broad money) of Suriname in 2009 to that in 2010?
Keep it short and to the point. 1. What is the ratio of the Claims(annual growth as % of broad money) in Cabo Verde in 2009 to that in 2011?
Keep it short and to the point. 0.75. What is the ratio of the Claims(annual growth as % of broad money) in Iraq in 2009 to that in 2011?
Provide a short and direct response. 0.33. What is the ratio of the Claims(annual growth as % of broad money) of Suriname in 2009 to that in 2011?
Keep it short and to the point. 0.63. What is the ratio of the Claims(annual growth as % of broad money) in Cabo Verde in 2010 to that in 2011?
Your answer should be compact. 0.63. What is the ratio of the Claims(annual growth as % of broad money) of Czech Republic in 2010 to that in 2011?
Keep it short and to the point. 0.24. What is the ratio of the Claims(annual growth as % of broad money) of Iraq in 2010 to that in 2011?
Your answer should be compact. 1.33. What is the ratio of the Claims(annual growth as % of broad money) of Suriname in 2010 to that in 2011?
Provide a short and direct response. 0.63. What is the difference between the highest and the second highest Claims(annual growth as % of broad money) of Cabo Verde?
Give a very brief answer. 1.1. What is the difference between the highest and the second highest Claims(annual growth as % of broad money) of Czech Republic?
Offer a very short reply. 3.95. What is the difference between the highest and the second highest Claims(annual growth as % of broad money) in Iraq?
Give a very brief answer. 0.45. What is the difference between the highest and the second highest Claims(annual growth as % of broad money) in Suriname?
Offer a very short reply. 0.96. What is the difference between the highest and the lowest Claims(annual growth as % of broad money) in Cabo Verde?
Provide a short and direct response. 10.79. What is the difference between the highest and the lowest Claims(annual growth as % of broad money) in Czech Republic?
Your answer should be compact. 19.17. What is the difference between the highest and the lowest Claims(annual growth as % of broad money) in Iraq?
Ensure brevity in your answer.  8.12. What is the difference between the highest and the lowest Claims(annual growth as % of broad money) in Suriname?
Ensure brevity in your answer.  10.49. 